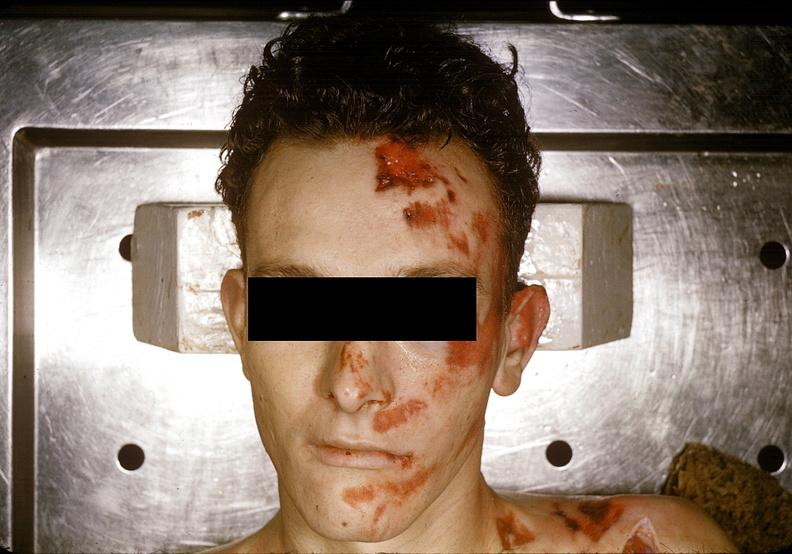what does this image show?
Answer the question using a single word or phrase. Head and face 